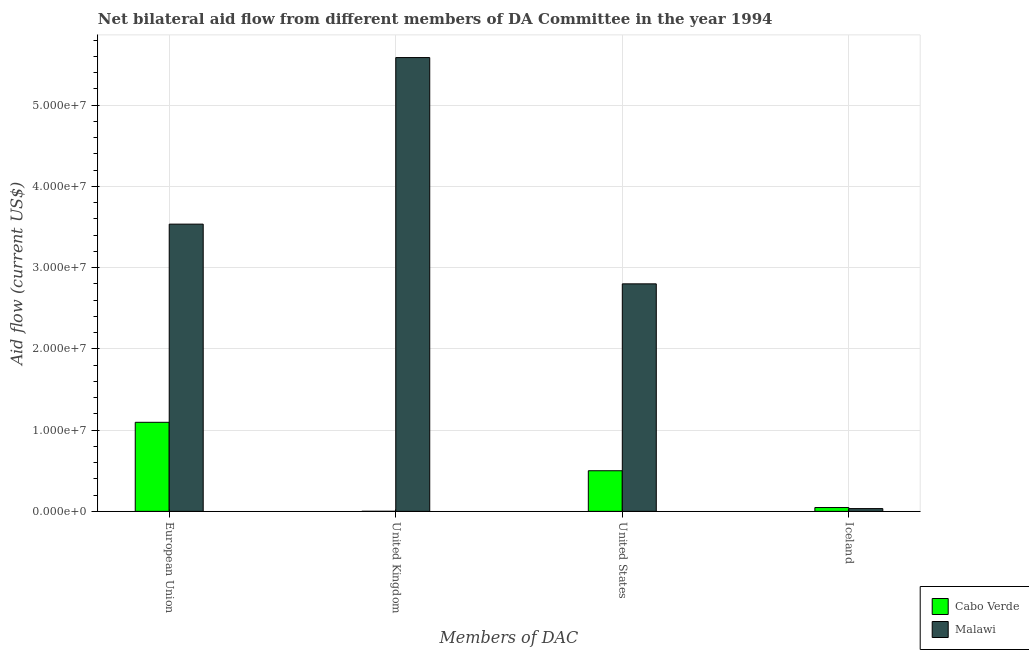How many different coloured bars are there?
Give a very brief answer. 2. How many groups of bars are there?
Keep it short and to the point. 4. Are the number of bars per tick equal to the number of legend labels?
Provide a succinct answer. Yes. How many bars are there on the 4th tick from the left?
Make the answer very short. 2. What is the amount of aid given by uk in Cabo Verde?
Offer a very short reply. 10000. Across all countries, what is the maximum amount of aid given by eu?
Provide a short and direct response. 3.54e+07. Across all countries, what is the minimum amount of aid given by eu?
Ensure brevity in your answer.  1.10e+07. In which country was the amount of aid given by iceland maximum?
Your response must be concise. Cabo Verde. In which country was the amount of aid given by eu minimum?
Ensure brevity in your answer.  Cabo Verde. What is the total amount of aid given by eu in the graph?
Your answer should be compact. 4.63e+07. What is the difference between the amount of aid given by iceland in Malawi and that in Cabo Verde?
Your answer should be very brief. -1.30e+05. What is the difference between the amount of aid given by uk in Cabo Verde and the amount of aid given by us in Malawi?
Your response must be concise. -2.80e+07. What is the average amount of aid given by us per country?
Offer a terse response. 1.65e+07. What is the difference between the amount of aid given by eu and amount of aid given by uk in Cabo Verde?
Offer a very short reply. 1.10e+07. What is the ratio of the amount of aid given by us in Malawi to that in Cabo Verde?
Offer a very short reply. 5.6. Is the amount of aid given by eu in Cabo Verde less than that in Malawi?
Offer a terse response. Yes. Is the difference between the amount of aid given by uk in Cabo Verde and Malawi greater than the difference between the amount of aid given by eu in Cabo Verde and Malawi?
Keep it short and to the point. No. What is the difference between the highest and the second highest amount of aid given by uk?
Offer a terse response. 5.58e+07. What is the difference between the highest and the lowest amount of aid given by iceland?
Your response must be concise. 1.30e+05. Is it the case that in every country, the sum of the amount of aid given by us and amount of aid given by eu is greater than the sum of amount of aid given by uk and amount of aid given by iceland?
Keep it short and to the point. No. What does the 1st bar from the left in United States represents?
Keep it short and to the point. Cabo Verde. What does the 1st bar from the right in Iceland represents?
Make the answer very short. Malawi. Is it the case that in every country, the sum of the amount of aid given by eu and amount of aid given by uk is greater than the amount of aid given by us?
Your answer should be very brief. Yes. How many countries are there in the graph?
Provide a short and direct response. 2. Are the values on the major ticks of Y-axis written in scientific E-notation?
Provide a succinct answer. Yes. What is the title of the graph?
Provide a succinct answer. Net bilateral aid flow from different members of DA Committee in the year 1994. What is the label or title of the X-axis?
Keep it short and to the point. Members of DAC. What is the Aid flow (current US$) in Cabo Verde in European Union?
Offer a very short reply. 1.10e+07. What is the Aid flow (current US$) of Malawi in European Union?
Your answer should be compact. 3.54e+07. What is the Aid flow (current US$) of Malawi in United Kingdom?
Your response must be concise. 5.58e+07. What is the Aid flow (current US$) of Malawi in United States?
Your answer should be very brief. 2.80e+07. What is the Aid flow (current US$) of Malawi in Iceland?
Keep it short and to the point. 3.40e+05. Across all Members of DAC, what is the maximum Aid flow (current US$) in Cabo Verde?
Offer a terse response. 1.10e+07. Across all Members of DAC, what is the maximum Aid flow (current US$) of Malawi?
Your response must be concise. 5.58e+07. Across all Members of DAC, what is the minimum Aid flow (current US$) of Cabo Verde?
Ensure brevity in your answer.  10000. Across all Members of DAC, what is the minimum Aid flow (current US$) in Malawi?
Your answer should be compact. 3.40e+05. What is the total Aid flow (current US$) of Cabo Verde in the graph?
Give a very brief answer. 1.64e+07. What is the total Aid flow (current US$) of Malawi in the graph?
Provide a succinct answer. 1.20e+08. What is the difference between the Aid flow (current US$) of Cabo Verde in European Union and that in United Kingdom?
Give a very brief answer. 1.10e+07. What is the difference between the Aid flow (current US$) of Malawi in European Union and that in United Kingdom?
Make the answer very short. -2.05e+07. What is the difference between the Aid flow (current US$) in Cabo Verde in European Union and that in United States?
Ensure brevity in your answer.  5.96e+06. What is the difference between the Aid flow (current US$) in Malawi in European Union and that in United States?
Provide a short and direct response. 7.35e+06. What is the difference between the Aid flow (current US$) of Cabo Verde in European Union and that in Iceland?
Provide a succinct answer. 1.05e+07. What is the difference between the Aid flow (current US$) of Malawi in European Union and that in Iceland?
Keep it short and to the point. 3.50e+07. What is the difference between the Aid flow (current US$) of Cabo Verde in United Kingdom and that in United States?
Your answer should be very brief. -4.99e+06. What is the difference between the Aid flow (current US$) in Malawi in United Kingdom and that in United States?
Offer a very short reply. 2.78e+07. What is the difference between the Aid flow (current US$) of Cabo Verde in United Kingdom and that in Iceland?
Your answer should be compact. -4.60e+05. What is the difference between the Aid flow (current US$) in Malawi in United Kingdom and that in Iceland?
Your response must be concise. 5.55e+07. What is the difference between the Aid flow (current US$) in Cabo Verde in United States and that in Iceland?
Offer a very short reply. 4.53e+06. What is the difference between the Aid flow (current US$) in Malawi in United States and that in Iceland?
Keep it short and to the point. 2.77e+07. What is the difference between the Aid flow (current US$) in Cabo Verde in European Union and the Aid flow (current US$) in Malawi in United Kingdom?
Ensure brevity in your answer.  -4.49e+07. What is the difference between the Aid flow (current US$) in Cabo Verde in European Union and the Aid flow (current US$) in Malawi in United States?
Make the answer very short. -1.70e+07. What is the difference between the Aid flow (current US$) of Cabo Verde in European Union and the Aid flow (current US$) of Malawi in Iceland?
Ensure brevity in your answer.  1.06e+07. What is the difference between the Aid flow (current US$) of Cabo Verde in United Kingdom and the Aid flow (current US$) of Malawi in United States?
Your answer should be very brief. -2.80e+07. What is the difference between the Aid flow (current US$) of Cabo Verde in United Kingdom and the Aid flow (current US$) of Malawi in Iceland?
Provide a short and direct response. -3.30e+05. What is the difference between the Aid flow (current US$) of Cabo Verde in United States and the Aid flow (current US$) of Malawi in Iceland?
Your answer should be compact. 4.66e+06. What is the average Aid flow (current US$) in Cabo Verde per Members of DAC?
Provide a succinct answer. 4.11e+06. What is the average Aid flow (current US$) in Malawi per Members of DAC?
Make the answer very short. 2.99e+07. What is the difference between the Aid flow (current US$) in Cabo Verde and Aid flow (current US$) in Malawi in European Union?
Ensure brevity in your answer.  -2.44e+07. What is the difference between the Aid flow (current US$) in Cabo Verde and Aid flow (current US$) in Malawi in United Kingdom?
Keep it short and to the point. -5.58e+07. What is the difference between the Aid flow (current US$) of Cabo Verde and Aid flow (current US$) of Malawi in United States?
Provide a succinct answer. -2.30e+07. What is the ratio of the Aid flow (current US$) in Cabo Verde in European Union to that in United Kingdom?
Ensure brevity in your answer.  1096. What is the ratio of the Aid flow (current US$) in Malawi in European Union to that in United Kingdom?
Your answer should be very brief. 0.63. What is the ratio of the Aid flow (current US$) in Cabo Verde in European Union to that in United States?
Keep it short and to the point. 2.19. What is the ratio of the Aid flow (current US$) of Malawi in European Union to that in United States?
Give a very brief answer. 1.26. What is the ratio of the Aid flow (current US$) in Cabo Verde in European Union to that in Iceland?
Your answer should be very brief. 23.32. What is the ratio of the Aid flow (current US$) of Malawi in European Union to that in Iceland?
Make the answer very short. 103.97. What is the ratio of the Aid flow (current US$) in Cabo Verde in United Kingdom to that in United States?
Make the answer very short. 0. What is the ratio of the Aid flow (current US$) in Malawi in United Kingdom to that in United States?
Offer a very short reply. 1.99. What is the ratio of the Aid flow (current US$) of Cabo Verde in United Kingdom to that in Iceland?
Make the answer very short. 0.02. What is the ratio of the Aid flow (current US$) in Malawi in United Kingdom to that in Iceland?
Your answer should be compact. 164.26. What is the ratio of the Aid flow (current US$) in Cabo Verde in United States to that in Iceland?
Provide a short and direct response. 10.64. What is the ratio of the Aid flow (current US$) in Malawi in United States to that in Iceland?
Your answer should be very brief. 82.35. What is the difference between the highest and the second highest Aid flow (current US$) of Cabo Verde?
Give a very brief answer. 5.96e+06. What is the difference between the highest and the second highest Aid flow (current US$) of Malawi?
Ensure brevity in your answer.  2.05e+07. What is the difference between the highest and the lowest Aid flow (current US$) of Cabo Verde?
Provide a succinct answer. 1.10e+07. What is the difference between the highest and the lowest Aid flow (current US$) in Malawi?
Offer a terse response. 5.55e+07. 